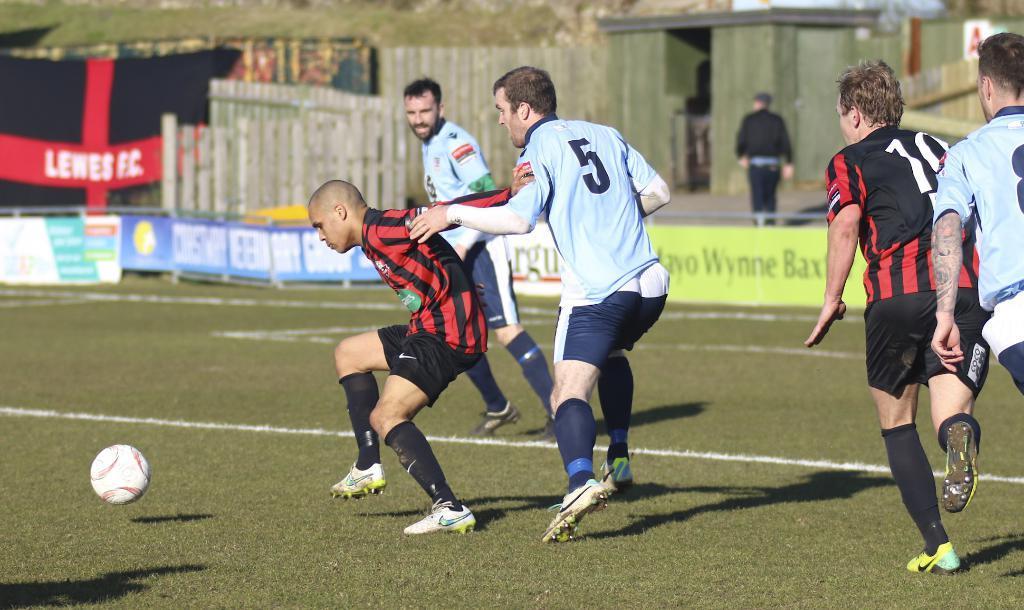Can you describe this image briefly? In this picture, we see five men are playing football game. At the bottom of the picture, we see grass and a ball. Beside them, we see board in red, white, blue and green color with some text written on it. Behind that, we see a man in black T-shirt is walking on the road. In front of him, we see a building in green color. 